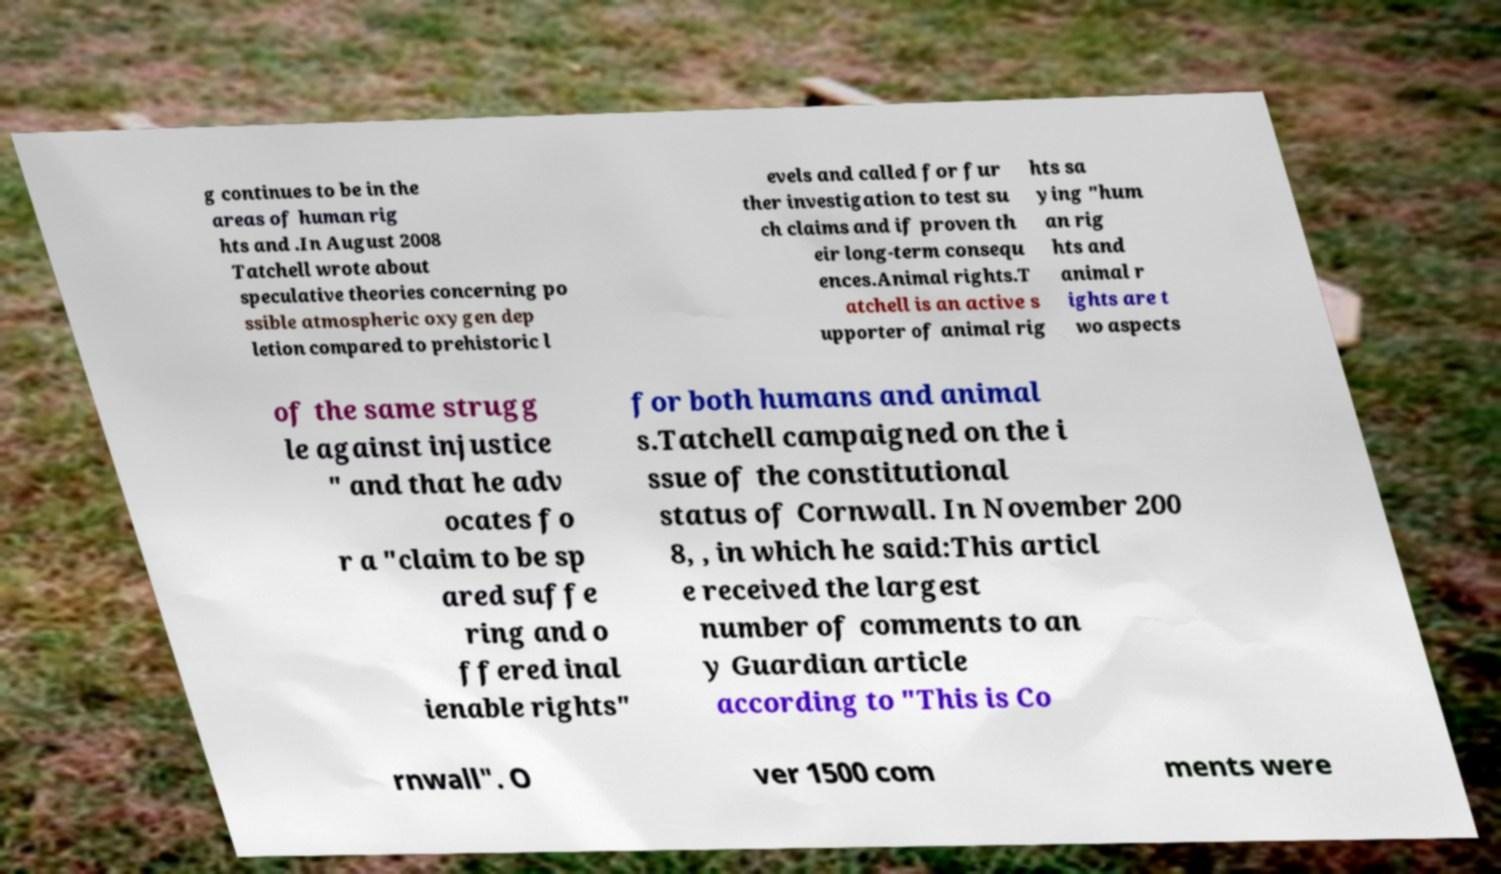For documentation purposes, I need the text within this image transcribed. Could you provide that? g continues to be in the areas of human rig hts and .In August 2008 Tatchell wrote about speculative theories concerning po ssible atmospheric oxygen dep letion compared to prehistoric l evels and called for fur ther investigation to test su ch claims and if proven th eir long-term consequ ences.Animal rights.T atchell is an active s upporter of animal rig hts sa ying "hum an rig hts and animal r ights are t wo aspects of the same strugg le against injustice " and that he adv ocates fo r a "claim to be sp ared suffe ring and o ffered inal ienable rights" for both humans and animal s.Tatchell campaigned on the i ssue of the constitutional status of Cornwall. In November 200 8, , in which he said:This articl e received the largest number of comments to an y Guardian article according to "This is Co rnwall". O ver 1500 com ments were 